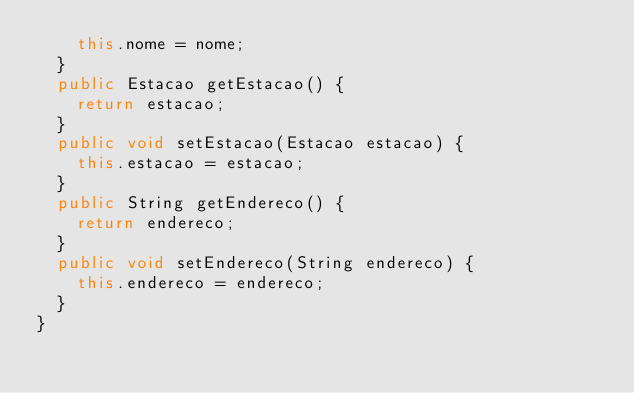Convert code to text. <code><loc_0><loc_0><loc_500><loc_500><_Java_>		this.nome = nome;
	}
	public Estacao getEstacao() {
		return estacao;
	}
	public void setEstacao(Estacao estacao) {
		this.estacao = estacao;
	}
	public String getEndereco() {
		return endereco;
	}
	public void setEndereco(String endereco) {
		this.endereco = endereco;
	}
}
</code> 